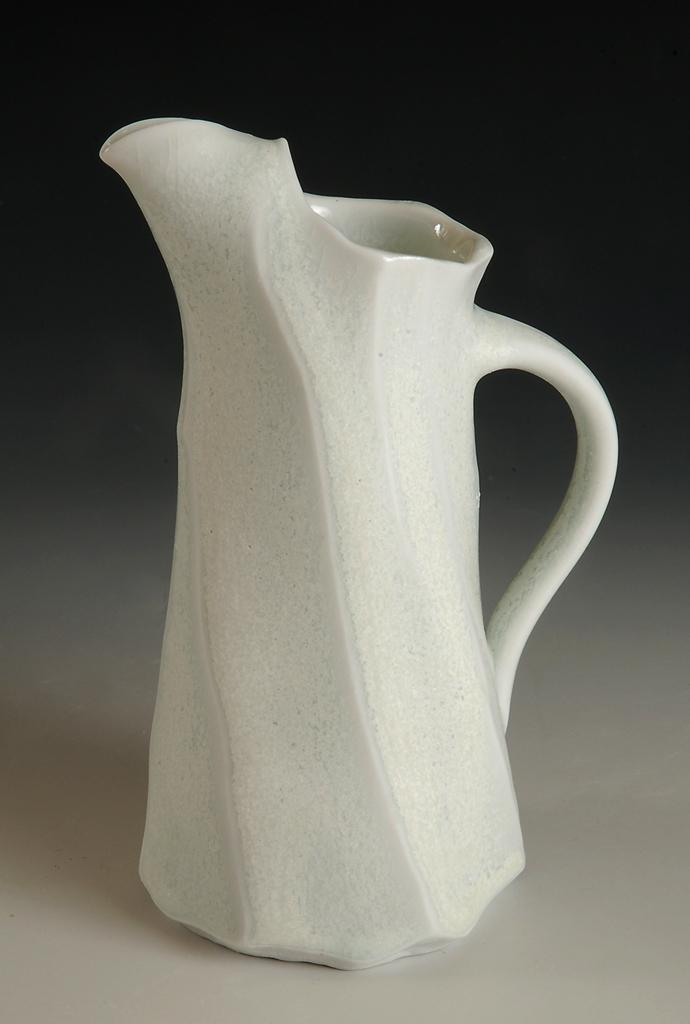What type of mug is visible in the image? There is a white color porcelain mug in the image. What color is the mug? The mug is white. What can be seen in the foreground of the image? The foreground of the image is white. What is the color of the background in the image? The background of the image is dark. What type of record can be seen spinning on the table in the image? There is no record present in the image; it only features a white color porcelain mug. Can you describe the friction between the mug and the table in the image? There is no information provided about the friction between the mug and the table, so it cannot be described. 